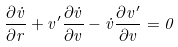<formula> <loc_0><loc_0><loc_500><loc_500>\frac { \partial \dot { v } } { \partial r } + v ^ { \prime } \frac { \partial \dot { v } } { \partial v } - \dot { v } \frac { \partial v ^ { \prime } } { \partial v } = 0</formula> 